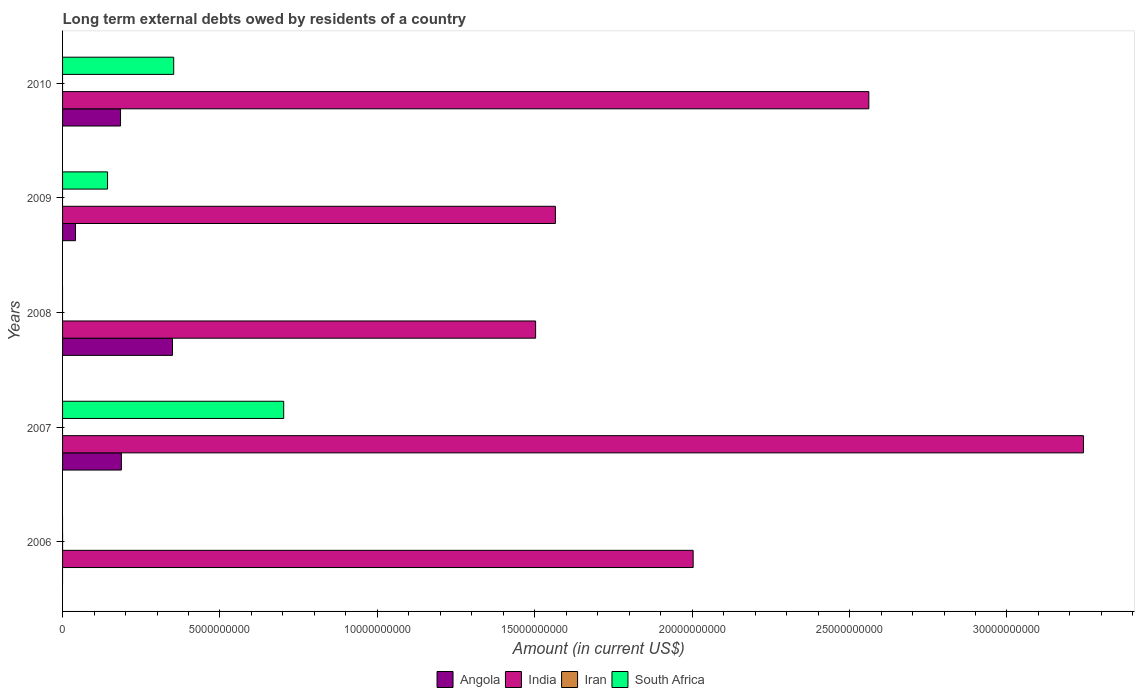Are the number of bars per tick equal to the number of legend labels?
Your answer should be compact. No. Are the number of bars on each tick of the Y-axis equal?
Provide a succinct answer. No. How many bars are there on the 3rd tick from the top?
Provide a succinct answer. 2. How many bars are there on the 5th tick from the bottom?
Make the answer very short. 3. In how many cases, is the number of bars for a given year not equal to the number of legend labels?
Provide a succinct answer. 5. What is the amount of long-term external debts owed by residents in South Africa in 2007?
Make the answer very short. 7.02e+09. Across all years, what is the maximum amount of long-term external debts owed by residents in Angola?
Make the answer very short. 3.49e+09. What is the difference between the amount of long-term external debts owed by residents in India in 2007 and that in 2009?
Make the answer very short. 1.68e+1. What is the difference between the amount of long-term external debts owed by residents in South Africa in 2006 and the amount of long-term external debts owed by residents in Iran in 2008?
Offer a very short reply. 0. What is the average amount of long-term external debts owed by residents in India per year?
Offer a very short reply. 2.18e+1. In the year 2008, what is the difference between the amount of long-term external debts owed by residents in India and amount of long-term external debts owed by residents in Angola?
Make the answer very short. 1.15e+1. In how many years, is the amount of long-term external debts owed by residents in India greater than 5000000000 US$?
Offer a very short reply. 5. Is the amount of long-term external debts owed by residents in India in 2008 less than that in 2010?
Give a very brief answer. Yes. Is the difference between the amount of long-term external debts owed by residents in India in 2007 and 2009 greater than the difference between the amount of long-term external debts owed by residents in Angola in 2007 and 2009?
Your answer should be compact. Yes. What is the difference between the highest and the second highest amount of long-term external debts owed by residents in India?
Give a very brief answer. 6.82e+09. What is the difference between the highest and the lowest amount of long-term external debts owed by residents in India?
Ensure brevity in your answer.  1.74e+1. Is it the case that in every year, the sum of the amount of long-term external debts owed by residents in Angola and amount of long-term external debts owed by residents in South Africa is greater than the sum of amount of long-term external debts owed by residents in Iran and amount of long-term external debts owed by residents in India?
Your answer should be compact. No. Are all the bars in the graph horizontal?
Offer a very short reply. Yes. What is the title of the graph?
Your answer should be compact. Long term external debts owed by residents of a country. Does "Middle income" appear as one of the legend labels in the graph?
Your response must be concise. No. What is the label or title of the X-axis?
Ensure brevity in your answer.  Amount (in current US$). What is the Amount (in current US$) in Angola in 2006?
Ensure brevity in your answer.  0. What is the Amount (in current US$) of India in 2006?
Provide a succinct answer. 2.00e+1. What is the Amount (in current US$) of South Africa in 2006?
Provide a short and direct response. 0. What is the Amount (in current US$) in Angola in 2007?
Provide a succinct answer. 1.87e+09. What is the Amount (in current US$) of India in 2007?
Offer a very short reply. 3.24e+1. What is the Amount (in current US$) in South Africa in 2007?
Ensure brevity in your answer.  7.02e+09. What is the Amount (in current US$) of Angola in 2008?
Your response must be concise. 3.49e+09. What is the Amount (in current US$) in India in 2008?
Provide a succinct answer. 1.50e+1. What is the Amount (in current US$) of South Africa in 2008?
Make the answer very short. 0. What is the Amount (in current US$) of Angola in 2009?
Your answer should be compact. 4.12e+08. What is the Amount (in current US$) in India in 2009?
Make the answer very short. 1.57e+1. What is the Amount (in current US$) in Iran in 2009?
Make the answer very short. 0. What is the Amount (in current US$) of South Africa in 2009?
Offer a very short reply. 1.43e+09. What is the Amount (in current US$) in Angola in 2010?
Your answer should be compact. 1.84e+09. What is the Amount (in current US$) in India in 2010?
Give a very brief answer. 2.56e+1. What is the Amount (in current US$) of South Africa in 2010?
Your response must be concise. 3.53e+09. Across all years, what is the maximum Amount (in current US$) in Angola?
Offer a terse response. 3.49e+09. Across all years, what is the maximum Amount (in current US$) in India?
Provide a short and direct response. 3.24e+1. Across all years, what is the maximum Amount (in current US$) of South Africa?
Offer a terse response. 7.02e+09. Across all years, what is the minimum Amount (in current US$) of India?
Offer a terse response. 1.50e+1. What is the total Amount (in current US$) of Angola in the graph?
Your answer should be compact. 7.61e+09. What is the total Amount (in current US$) in India in the graph?
Keep it short and to the point. 1.09e+11. What is the total Amount (in current US$) of Iran in the graph?
Your answer should be compact. 0. What is the total Amount (in current US$) in South Africa in the graph?
Keep it short and to the point. 1.20e+1. What is the difference between the Amount (in current US$) of India in 2006 and that in 2007?
Your answer should be compact. -1.24e+1. What is the difference between the Amount (in current US$) of India in 2006 and that in 2008?
Make the answer very short. 5.00e+09. What is the difference between the Amount (in current US$) of India in 2006 and that in 2009?
Your answer should be compact. 4.38e+09. What is the difference between the Amount (in current US$) of India in 2006 and that in 2010?
Provide a short and direct response. -5.58e+09. What is the difference between the Amount (in current US$) of Angola in 2007 and that in 2008?
Offer a very short reply. -1.62e+09. What is the difference between the Amount (in current US$) in India in 2007 and that in 2008?
Keep it short and to the point. 1.74e+1. What is the difference between the Amount (in current US$) in Angola in 2007 and that in 2009?
Give a very brief answer. 1.46e+09. What is the difference between the Amount (in current US$) of India in 2007 and that in 2009?
Offer a very short reply. 1.68e+1. What is the difference between the Amount (in current US$) in South Africa in 2007 and that in 2009?
Your response must be concise. 5.60e+09. What is the difference between the Amount (in current US$) in Angola in 2007 and that in 2010?
Make the answer very short. 2.74e+07. What is the difference between the Amount (in current US$) in India in 2007 and that in 2010?
Offer a very short reply. 6.82e+09. What is the difference between the Amount (in current US$) in South Africa in 2007 and that in 2010?
Your response must be concise. 3.49e+09. What is the difference between the Amount (in current US$) in Angola in 2008 and that in 2009?
Offer a terse response. 3.08e+09. What is the difference between the Amount (in current US$) in India in 2008 and that in 2009?
Keep it short and to the point. -6.29e+08. What is the difference between the Amount (in current US$) of Angola in 2008 and that in 2010?
Give a very brief answer. 1.65e+09. What is the difference between the Amount (in current US$) in India in 2008 and that in 2010?
Provide a succinct answer. -1.06e+1. What is the difference between the Amount (in current US$) of Angola in 2009 and that in 2010?
Provide a succinct answer. -1.43e+09. What is the difference between the Amount (in current US$) in India in 2009 and that in 2010?
Your answer should be very brief. -9.96e+09. What is the difference between the Amount (in current US$) of South Africa in 2009 and that in 2010?
Give a very brief answer. -2.10e+09. What is the difference between the Amount (in current US$) in India in 2006 and the Amount (in current US$) in South Africa in 2007?
Ensure brevity in your answer.  1.30e+1. What is the difference between the Amount (in current US$) of India in 2006 and the Amount (in current US$) of South Africa in 2009?
Offer a very short reply. 1.86e+1. What is the difference between the Amount (in current US$) of India in 2006 and the Amount (in current US$) of South Africa in 2010?
Ensure brevity in your answer.  1.65e+1. What is the difference between the Amount (in current US$) in Angola in 2007 and the Amount (in current US$) in India in 2008?
Your response must be concise. -1.32e+1. What is the difference between the Amount (in current US$) in Angola in 2007 and the Amount (in current US$) in India in 2009?
Your answer should be very brief. -1.38e+1. What is the difference between the Amount (in current US$) in Angola in 2007 and the Amount (in current US$) in South Africa in 2009?
Your answer should be very brief. 4.40e+08. What is the difference between the Amount (in current US$) of India in 2007 and the Amount (in current US$) of South Africa in 2009?
Offer a very short reply. 3.10e+1. What is the difference between the Amount (in current US$) of Angola in 2007 and the Amount (in current US$) of India in 2010?
Make the answer very short. -2.37e+1. What is the difference between the Amount (in current US$) in Angola in 2007 and the Amount (in current US$) in South Africa in 2010?
Provide a succinct answer. -1.66e+09. What is the difference between the Amount (in current US$) in India in 2007 and the Amount (in current US$) in South Africa in 2010?
Your answer should be very brief. 2.89e+1. What is the difference between the Amount (in current US$) of Angola in 2008 and the Amount (in current US$) of India in 2009?
Your answer should be compact. -1.22e+1. What is the difference between the Amount (in current US$) of Angola in 2008 and the Amount (in current US$) of South Africa in 2009?
Make the answer very short. 2.06e+09. What is the difference between the Amount (in current US$) of India in 2008 and the Amount (in current US$) of South Africa in 2009?
Give a very brief answer. 1.36e+1. What is the difference between the Amount (in current US$) of Angola in 2008 and the Amount (in current US$) of India in 2010?
Give a very brief answer. -2.21e+1. What is the difference between the Amount (in current US$) of Angola in 2008 and the Amount (in current US$) of South Africa in 2010?
Give a very brief answer. -3.85e+07. What is the difference between the Amount (in current US$) in India in 2008 and the Amount (in current US$) in South Africa in 2010?
Ensure brevity in your answer.  1.15e+1. What is the difference between the Amount (in current US$) of Angola in 2009 and the Amount (in current US$) of India in 2010?
Make the answer very short. -2.52e+1. What is the difference between the Amount (in current US$) in Angola in 2009 and the Amount (in current US$) in South Africa in 2010?
Your answer should be compact. -3.12e+09. What is the difference between the Amount (in current US$) in India in 2009 and the Amount (in current US$) in South Africa in 2010?
Offer a terse response. 1.21e+1. What is the average Amount (in current US$) of Angola per year?
Make the answer very short. 1.52e+09. What is the average Amount (in current US$) of India per year?
Provide a succinct answer. 2.18e+1. What is the average Amount (in current US$) in Iran per year?
Make the answer very short. 0. What is the average Amount (in current US$) in South Africa per year?
Give a very brief answer. 2.40e+09. In the year 2007, what is the difference between the Amount (in current US$) in Angola and Amount (in current US$) in India?
Your answer should be compact. -3.06e+1. In the year 2007, what is the difference between the Amount (in current US$) of Angola and Amount (in current US$) of South Africa?
Give a very brief answer. -5.16e+09. In the year 2007, what is the difference between the Amount (in current US$) in India and Amount (in current US$) in South Africa?
Offer a very short reply. 2.54e+1. In the year 2008, what is the difference between the Amount (in current US$) in Angola and Amount (in current US$) in India?
Provide a short and direct response. -1.15e+1. In the year 2009, what is the difference between the Amount (in current US$) of Angola and Amount (in current US$) of India?
Provide a short and direct response. -1.52e+1. In the year 2009, what is the difference between the Amount (in current US$) in Angola and Amount (in current US$) in South Africa?
Provide a short and direct response. -1.02e+09. In the year 2009, what is the difference between the Amount (in current US$) in India and Amount (in current US$) in South Africa?
Ensure brevity in your answer.  1.42e+1. In the year 2010, what is the difference between the Amount (in current US$) of Angola and Amount (in current US$) of India?
Ensure brevity in your answer.  -2.38e+1. In the year 2010, what is the difference between the Amount (in current US$) in Angola and Amount (in current US$) in South Africa?
Give a very brief answer. -1.69e+09. In the year 2010, what is the difference between the Amount (in current US$) in India and Amount (in current US$) in South Africa?
Give a very brief answer. 2.21e+1. What is the ratio of the Amount (in current US$) in India in 2006 to that in 2007?
Give a very brief answer. 0.62. What is the ratio of the Amount (in current US$) of India in 2006 to that in 2008?
Give a very brief answer. 1.33. What is the ratio of the Amount (in current US$) in India in 2006 to that in 2009?
Make the answer very short. 1.28. What is the ratio of the Amount (in current US$) in India in 2006 to that in 2010?
Provide a succinct answer. 0.78. What is the ratio of the Amount (in current US$) of Angola in 2007 to that in 2008?
Your answer should be compact. 0.54. What is the ratio of the Amount (in current US$) of India in 2007 to that in 2008?
Offer a very short reply. 2.16. What is the ratio of the Amount (in current US$) of Angola in 2007 to that in 2009?
Your answer should be compact. 4.54. What is the ratio of the Amount (in current US$) in India in 2007 to that in 2009?
Your answer should be compact. 2.07. What is the ratio of the Amount (in current US$) of South Africa in 2007 to that in 2009?
Keep it short and to the point. 4.92. What is the ratio of the Amount (in current US$) of Angola in 2007 to that in 2010?
Provide a succinct answer. 1.01. What is the ratio of the Amount (in current US$) of India in 2007 to that in 2010?
Give a very brief answer. 1.27. What is the ratio of the Amount (in current US$) of South Africa in 2007 to that in 2010?
Provide a short and direct response. 1.99. What is the ratio of the Amount (in current US$) in Angola in 2008 to that in 2009?
Keep it short and to the point. 8.48. What is the ratio of the Amount (in current US$) in India in 2008 to that in 2009?
Provide a short and direct response. 0.96. What is the ratio of the Amount (in current US$) of Angola in 2008 to that in 2010?
Your response must be concise. 1.9. What is the ratio of the Amount (in current US$) of India in 2008 to that in 2010?
Make the answer very short. 0.59. What is the ratio of the Amount (in current US$) of Angola in 2009 to that in 2010?
Give a very brief answer. 0.22. What is the ratio of the Amount (in current US$) of India in 2009 to that in 2010?
Offer a very short reply. 0.61. What is the ratio of the Amount (in current US$) of South Africa in 2009 to that in 2010?
Provide a succinct answer. 0.4. What is the difference between the highest and the second highest Amount (in current US$) of Angola?
Your response must be concise. 1.62e+09. What is the difference between the highest and the second highest Amount (in current US$) of India?
Provide a short and direct response. 6.82e+09. What is the difference between the highest and the second highest Amount (in current US$) of South Africa?
Ensure brevity in your answer.  3.49e+09. What is the difference between the highest and the lowest Amount (in current US$) of Angola?
Offer a very short reply. 3.49e+09. What is the difference between the highest and the lowest Amount (in current US$) of India?
Your answer should be compact. 1.74e+1. What is the difference between the highest and the lowest Amount (in current US$) in South Africa?
Ensure brevity in your answer.  7.02e+09. 